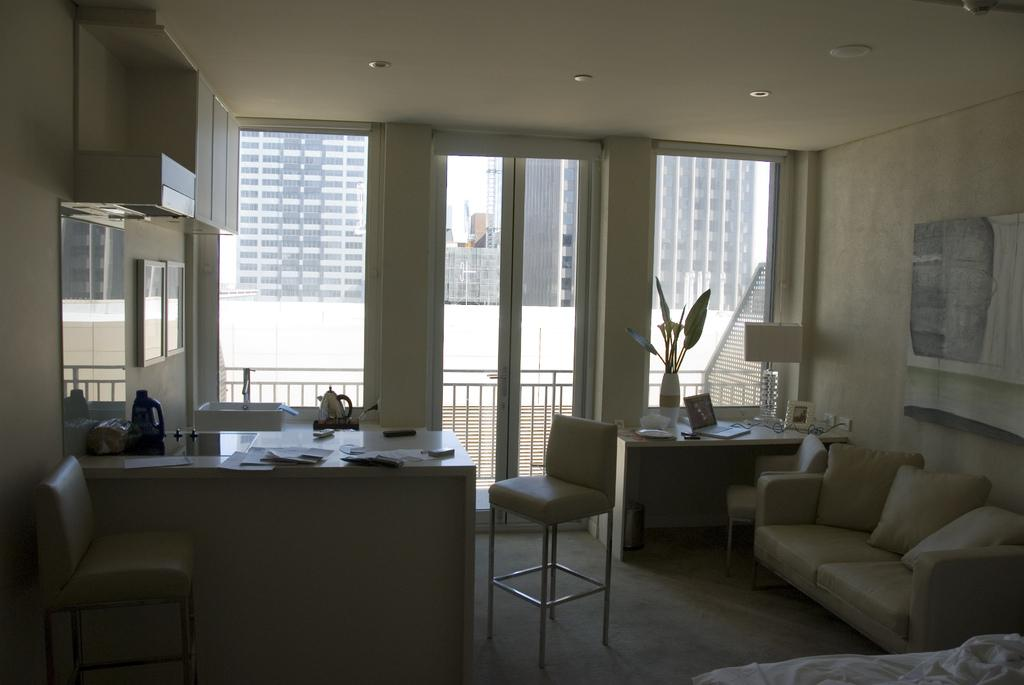How many seating options are visible in the image? There are three chairs and a couch in the image, providing a total of four seating options. What type of objects can be seen on the table in the image? There are papers and a jug on the table in the image. How many pillows are present in the image? There are three pillows in the image. What can be seen in the background of the image? There is a building and a glass in the background of the image. Where is the light visible in the image? The light is visible at the top of the image. How many owls are sitting on the couch in the image? There are no owls present in the image. How long does it take for the minute hand to move one minute in the image? There is no clock or time-related object in the image, so it is not possible to determine how long it takes for the minute hand to move one minute. 